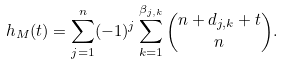<formula> <loc_0><loc_0><loc_500><loc_500>h _ { M } ( t ) = \sum _ { j = 1 } ^ { n } ( - 1 ) ^ { j } \sum _ { k = 1 } ^ { { \beta } _ { j , k } } { n + d _ { j , k } + t \choose n } .</formula> 